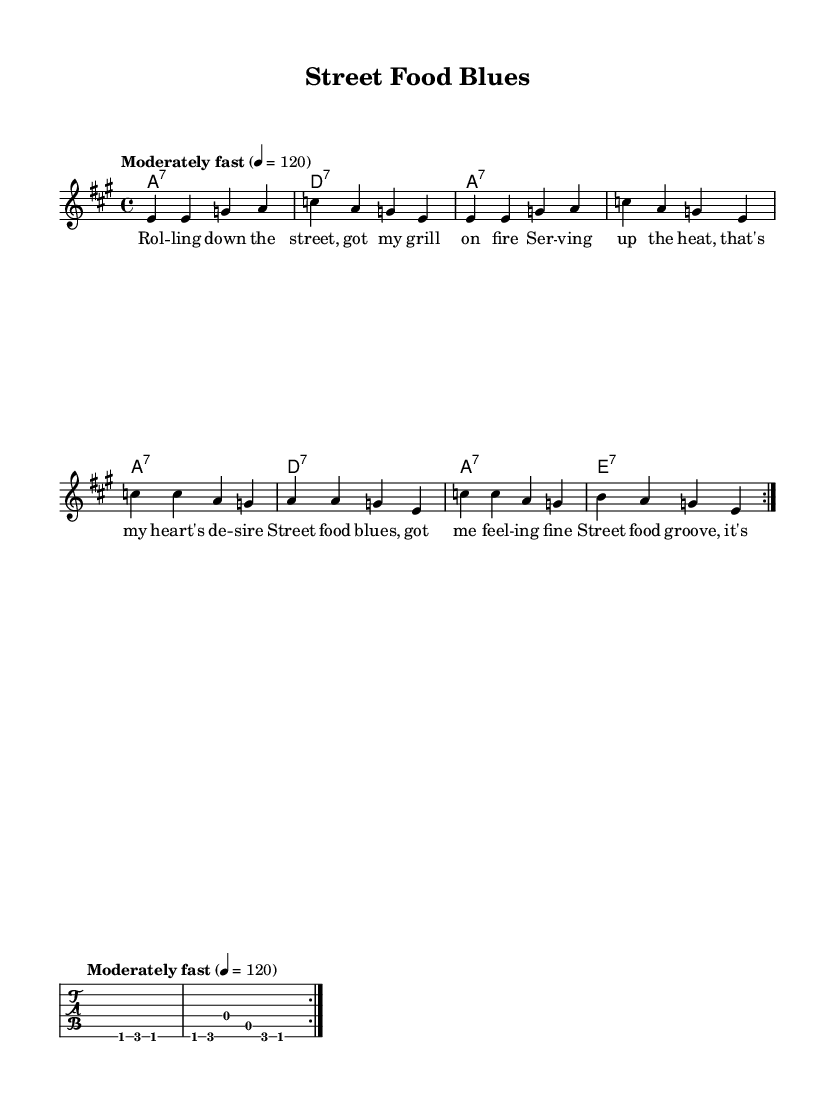What is the key signature of this music? The key signature is A major, which has three sharps: F sharp, C sharp, and G sharp.
Answer: A major What is the time signature of this piece? The time signature is indicated at the beginning of the score and shows that there are four beats per measure.
Answer: 4/4 What is the tempo marking for this piece? The tempo marking indicates that the music should be played moderately fast, with a speed of 120 beats per minute.
Answer: Moderately fast, 120 How many times is the melody repeated in the first section? The melody section has a repeat sign indicating that the melody should be played twice in this section.
Answer: 2 What type of chords are used in the harmonies? The chords are seventh chords, as denoted by the "7" in the chord symbols such as A7 and D7.
Answer: Seventh chords What is the primary theme of the lyrics in the first verse? The lyrics express a celebration of street food culture, highlighting cooking and serving delicious food.
Answer: Street food culture What musical element characterizes blues music in this piece? The piece features a call-and-response format, typical of blues, evident in the riffs and lyrical phrases.
Answer: Call-and-response 